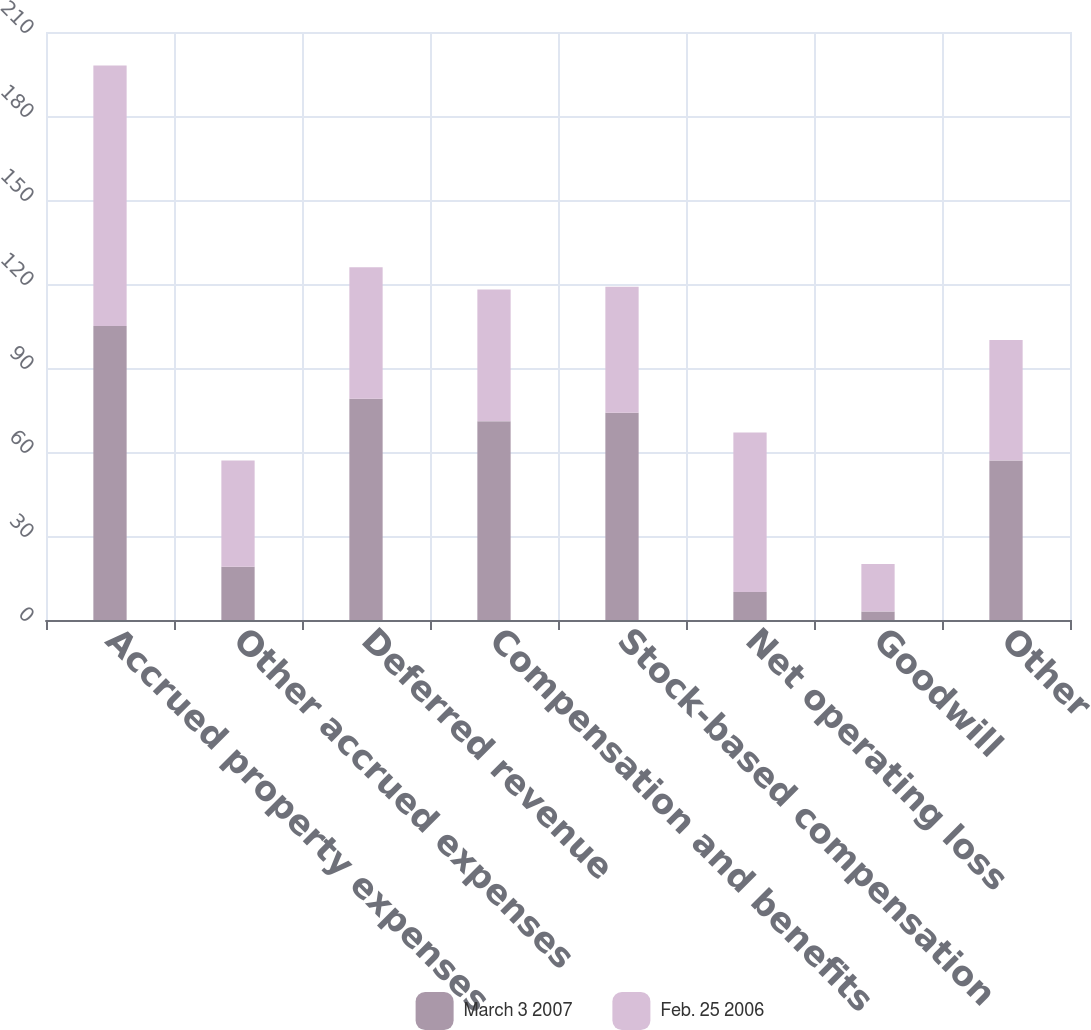Convert chart. <chart><loc_0><loc_0><loc_500><loc_500><stacked_bar_chart><ecel><fcel>Accrued property expenses<fcel>Other accrued expenses<fcel>Deferred revenue<fcel>Compensation and benefits<fcel>Stock-based compensation<fcel>Net operating loss<fcel>Goodwill<fcel>Other<nl><fcel>March 3 2007<fcel>105<fcel>19<fcel>79<fcel>71<fcel>74<fcel>10<fcel>3<fcel>57<nl><fcel>Feb. 25 2006<fcel>93<fcel>38<fcel>47<fcel>47<fcel>45<fcel>57<fcel>17<fcel>43<nl></chart> 